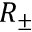<formula> <loc_0><loc_0><loc_500><loc_500>R _ { \pm }</formula> 